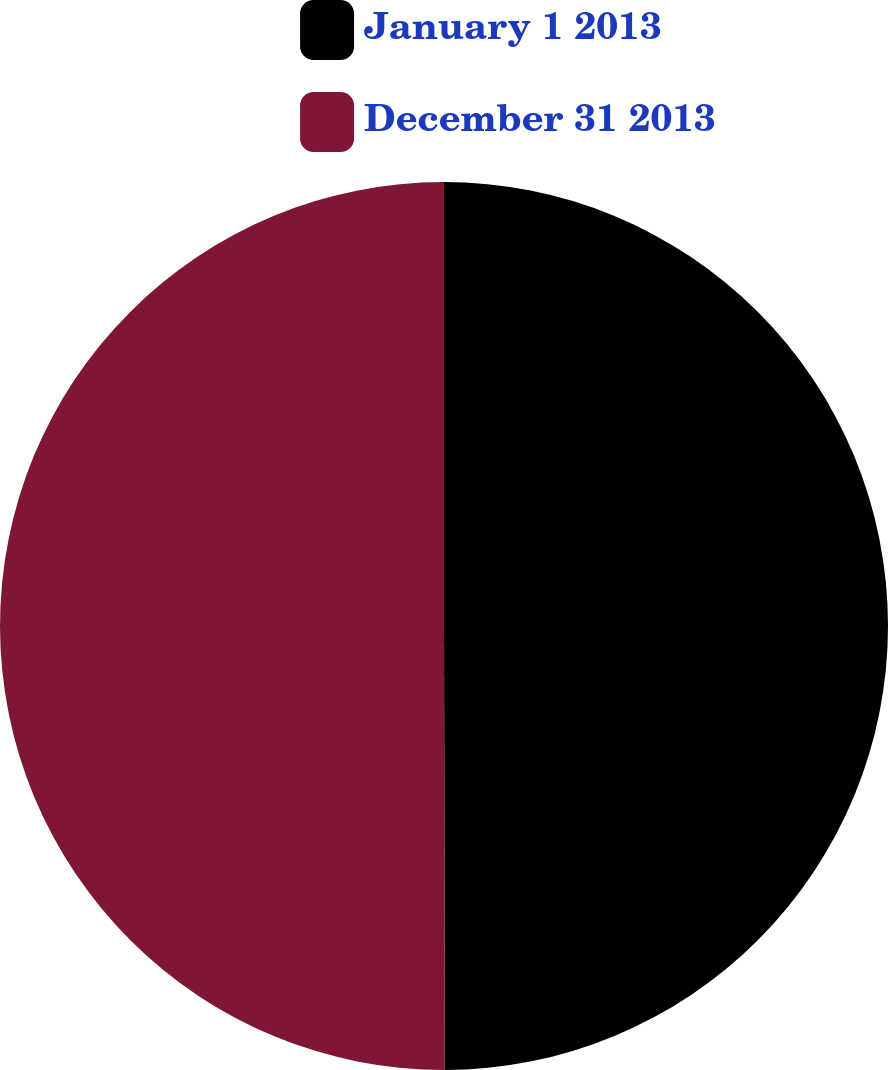<chart> <loc_0><loc_0><loc_500><loc_500><pie_chart><fcel>January 1 2013<fcel>December 31 2013<nl><fcel>49.97%<fcel>50.03%<nl></chart> 